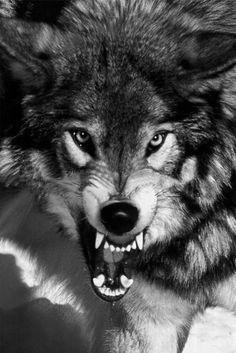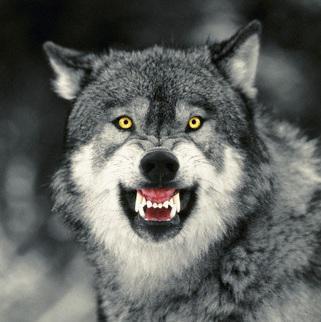The first image is the image on the left, the second image is the image on the right. Analyze the images presented: Is the assertion "The dog on the right is baring its teeth." valid? Answer yes or no. Yes. The first image is the image on the left, the second image is the image on the right. For the images displayed, is the sentence "At least one image shows a wolf baring its fangs." factually correct? Answer yes or no. Yes. 